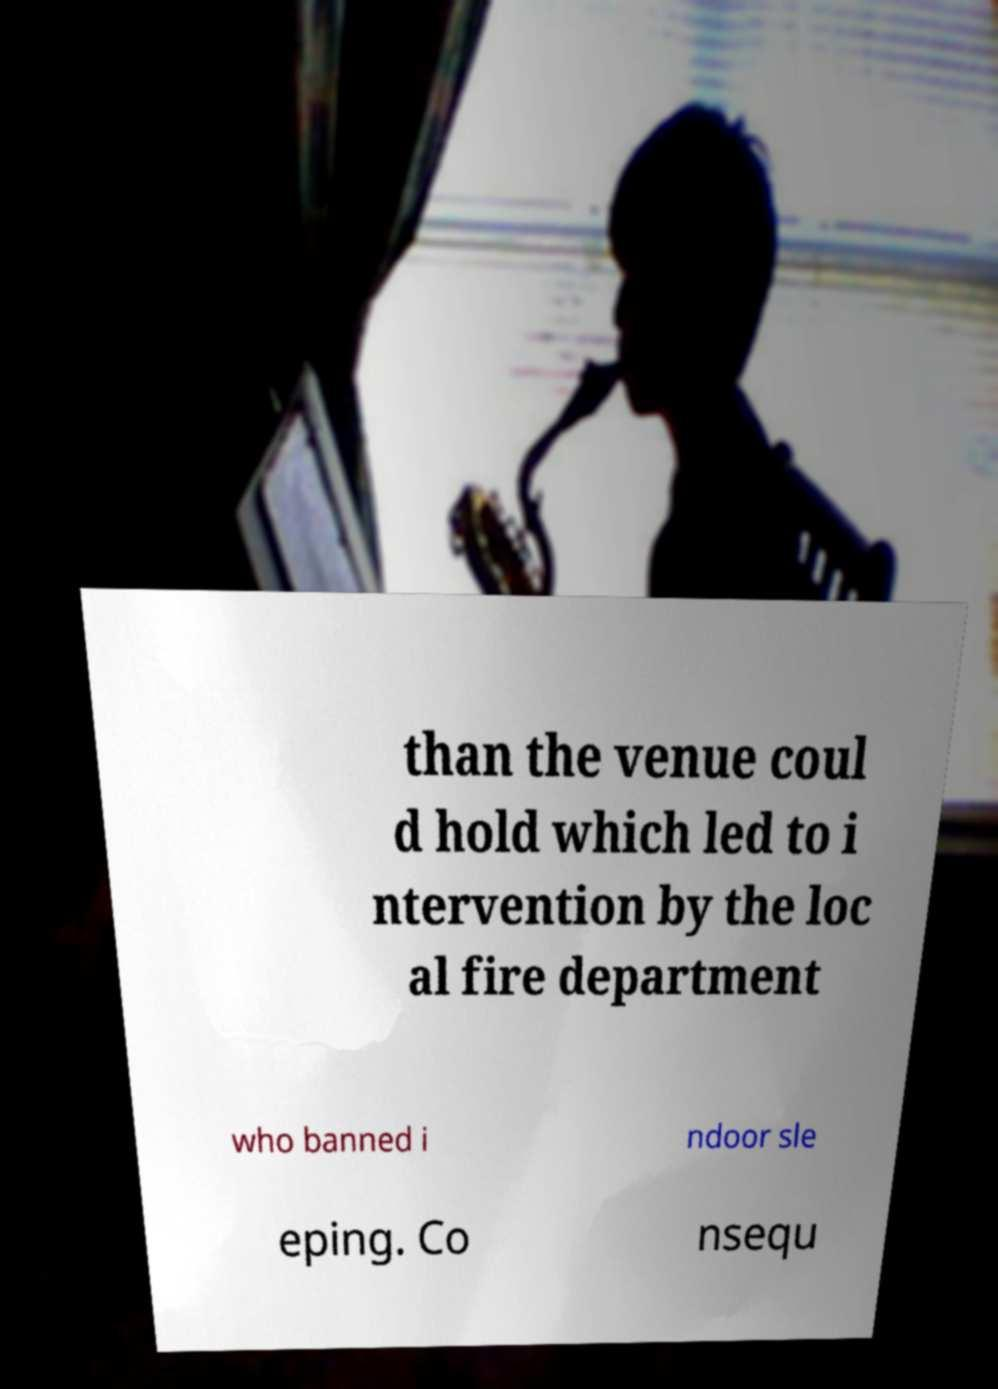For documentation purposes, I need the text within this image transcribed. Could you provide that? than the venue coul d hold which led to i ntervention by the loc al fire department who banned i ndoor sle eping. Co nsequ 